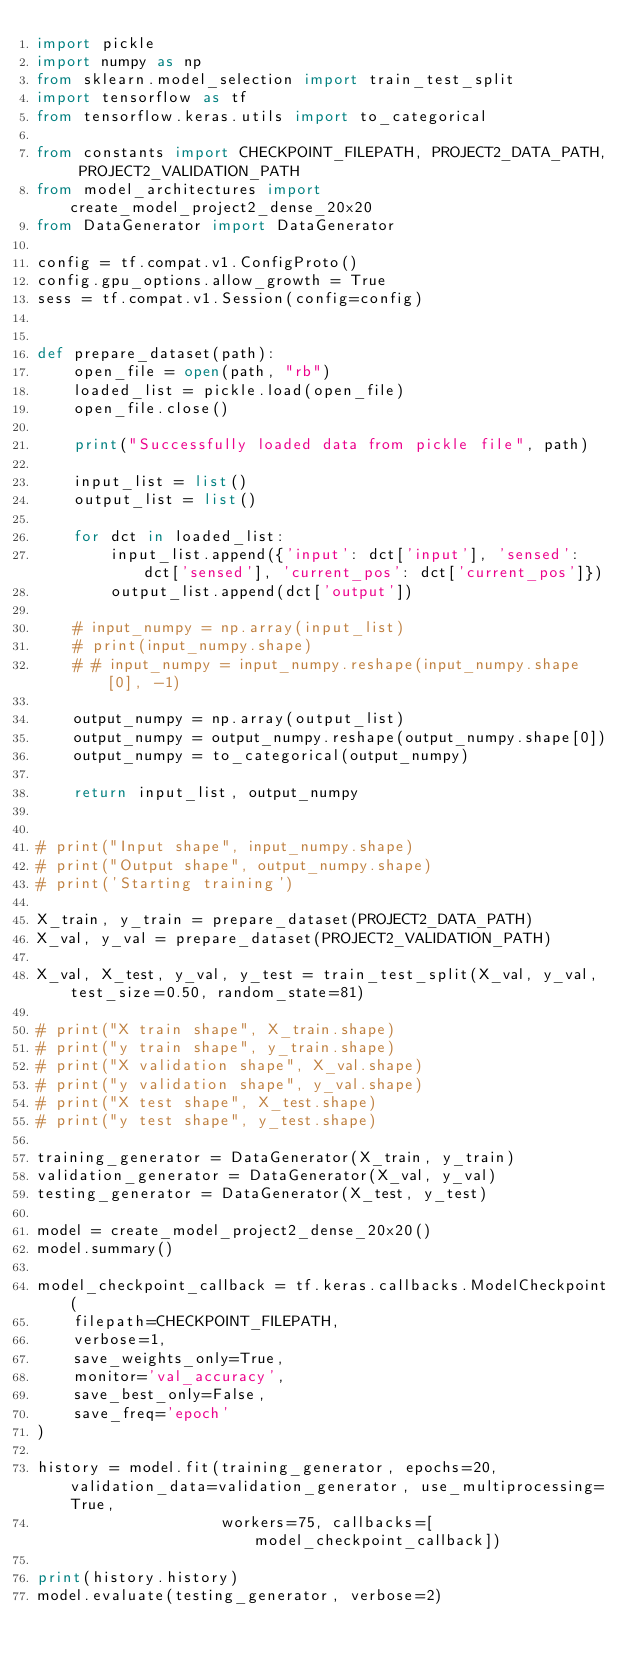Convert code to text. <code><loc_0><loc_0><loc_500><loc_500><_Python_>import pickle
import numpy as np
from sklearn.model_selection import train_test_split
import tensorflow as tf
from tensorflow.keras.utils import to_categorical

from constants import CHECKPOINT_FILEPATH, PROJECT2_DATA_PATH, PROJECT2_VALIDATION_PATH
from model_architectures import create_model_project2_dense_20x20
from DataGenerator import DataGenerator

config = tf.compat.v1.ConfigProto()
config.gpu_options.allow_growth = True
sess = tf.compat.v1.Session(config=config)


def prepare_dataset(path):
    open_file = open(path, "rb")
    loaded_list = pickle.load(open_file)
    open_file.close()

    print("Successfully loaded data from pickle file", path)

    input_list = list()
    output_list = list()

    for dct in loaded_list:
        input_list.append({'input': dct['input'], 'sensed': dct['sensed'], 'current_pos': dct['current_pos']})
        output_list.append(dct['output'])

    # input_numpy = np.array(input_list)
    # print(input_numpy.shape)
    # # input_numpy = input_numpy.reshape(input_numpy.shape[0], -1)

    output_numpy = np.array(output_list)
    output_numpy = output_numpy.reshape(output_numpy.shape[0])
    output_numpy = to_categorical(output_numpy)

    return input_list, output_numpy


# print("Input shape", input_numpy.shape)
# print("Output shape", output_numpy.shape)
# print('Starting training')

X_train, y_train = prepare_dataset(PROJECT2_DATA_PATH)
X_val, y_val = prepare_dataset(PROJECT2_VALIDATION_PATH)

X_val, X_test, y_val, y_test = train_test_split(X_val, y_val, test_size=0.50, random_state=81)

# print("X train shape", X_train.shape)
# print("y train shape", y_train.shape)
# print("X validation shape", X_val.shape)
# print("y validation shape", y_val.shape)
# print("X test shape", X_test.shape)
# print("y test shape", y_test.shape)

training_generator = DataGenerator(X_train, y_train)
validation_generator = DataGenerator(X_val, y_val)
testing_generator = DataGenerator(X_test, y_test)

model = create_model_project2_dense_20x20()
model.summary()

model_checkpoint_callback = tf.keras.callbacks.ModelCheckpoint(
    filepath=CHECKPOINT_FILEPATH,
    verbose=1,
    save_weights_only=True,
    monitor='val_accuracy',
    save_best_only=False,
    save_freq='epoch'
)

history = model.fit(training_generator, epochs=20, validation_data=validation_generator, use_multiprocessing=True,
                    workers=75, callbacks=[model_checkpoint_callback])

print(history.history)
model.evaluate(testing_generator, verbose=2)
</code> 